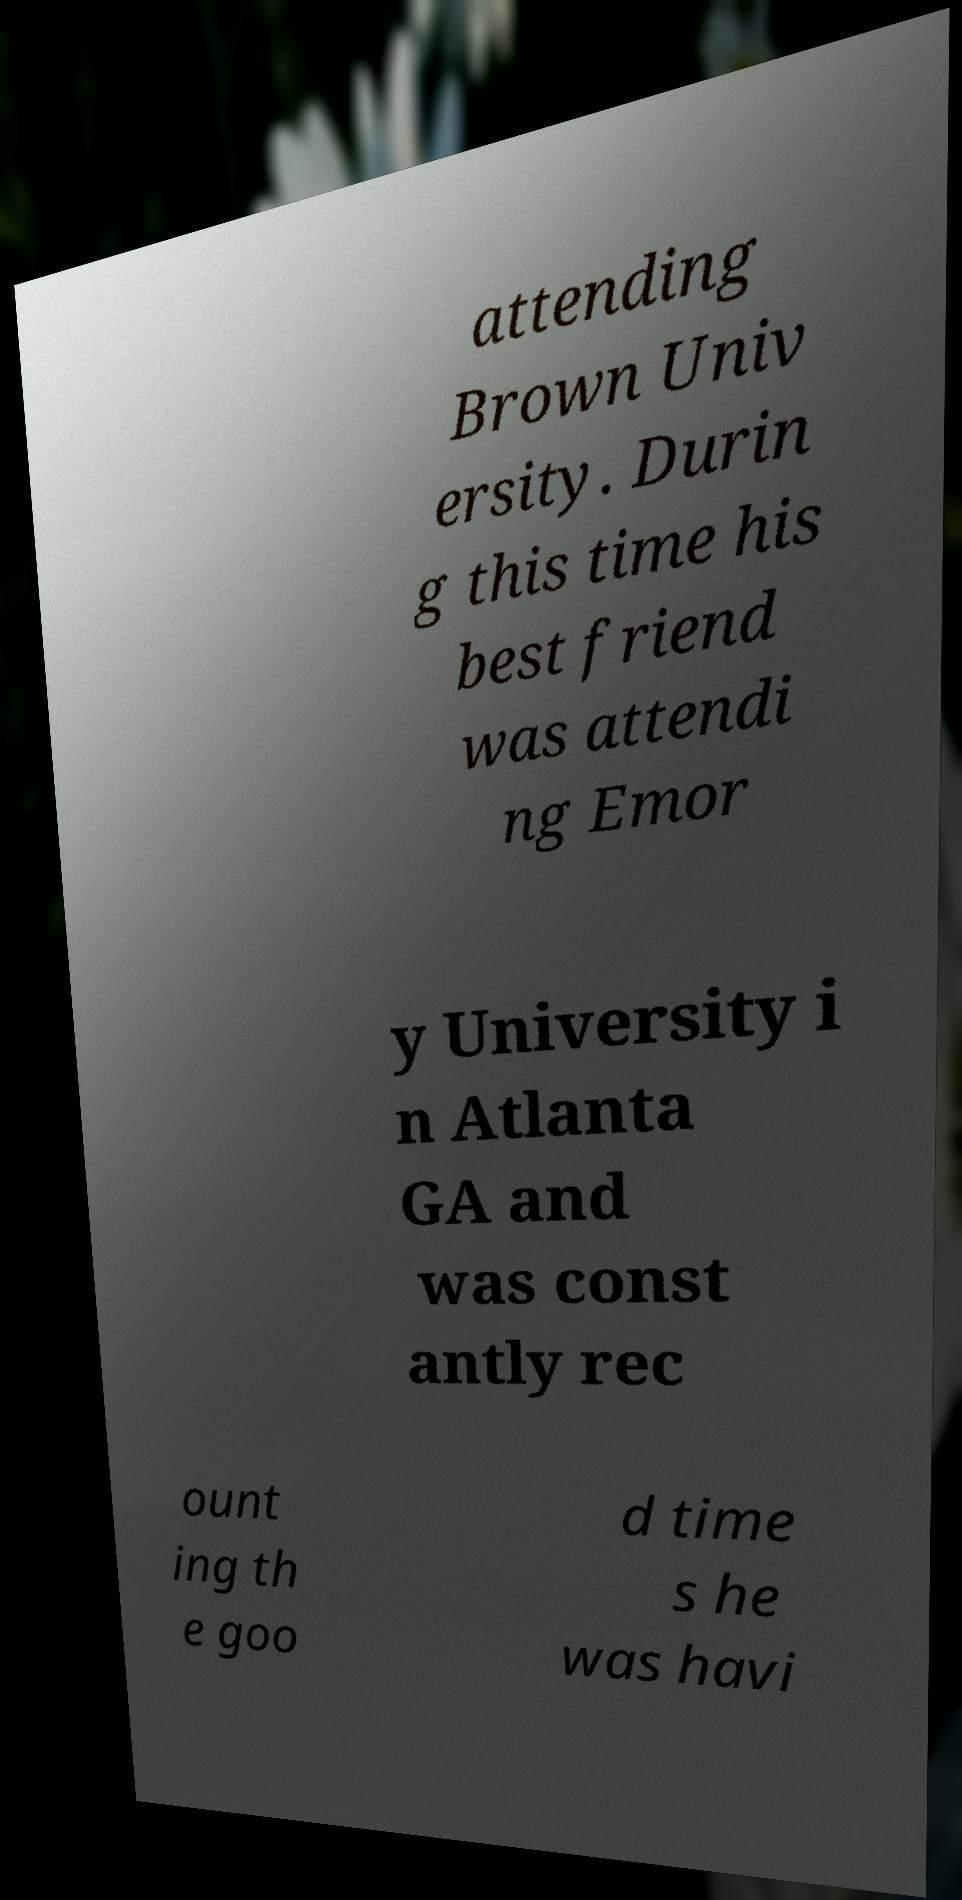Please identify and transcribe the text found in this image. attending Brown Univ ersity. Durin g this time his best friend was attendi ng Emor y University i n Atlanta GA and was const antly rec ount ing th e goo d time s he was havi 